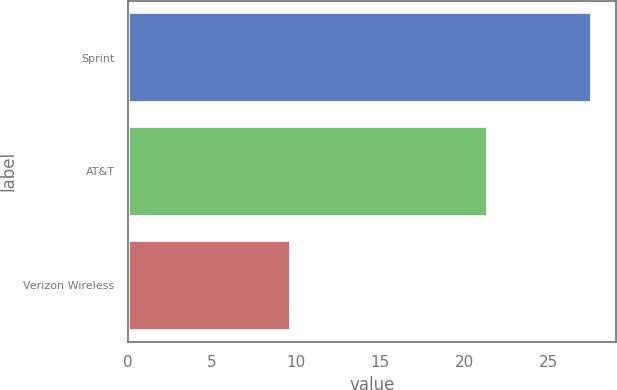Convert chart. <chart><loc_0><loc_0><loc_500><loc_500><bar_chart><fcel>Sprint<fcel>AT&T<fcel>Verizon Wireless<nl><fcel>27.6<fcel>21.4<fcel>9.7<nl></chart> 